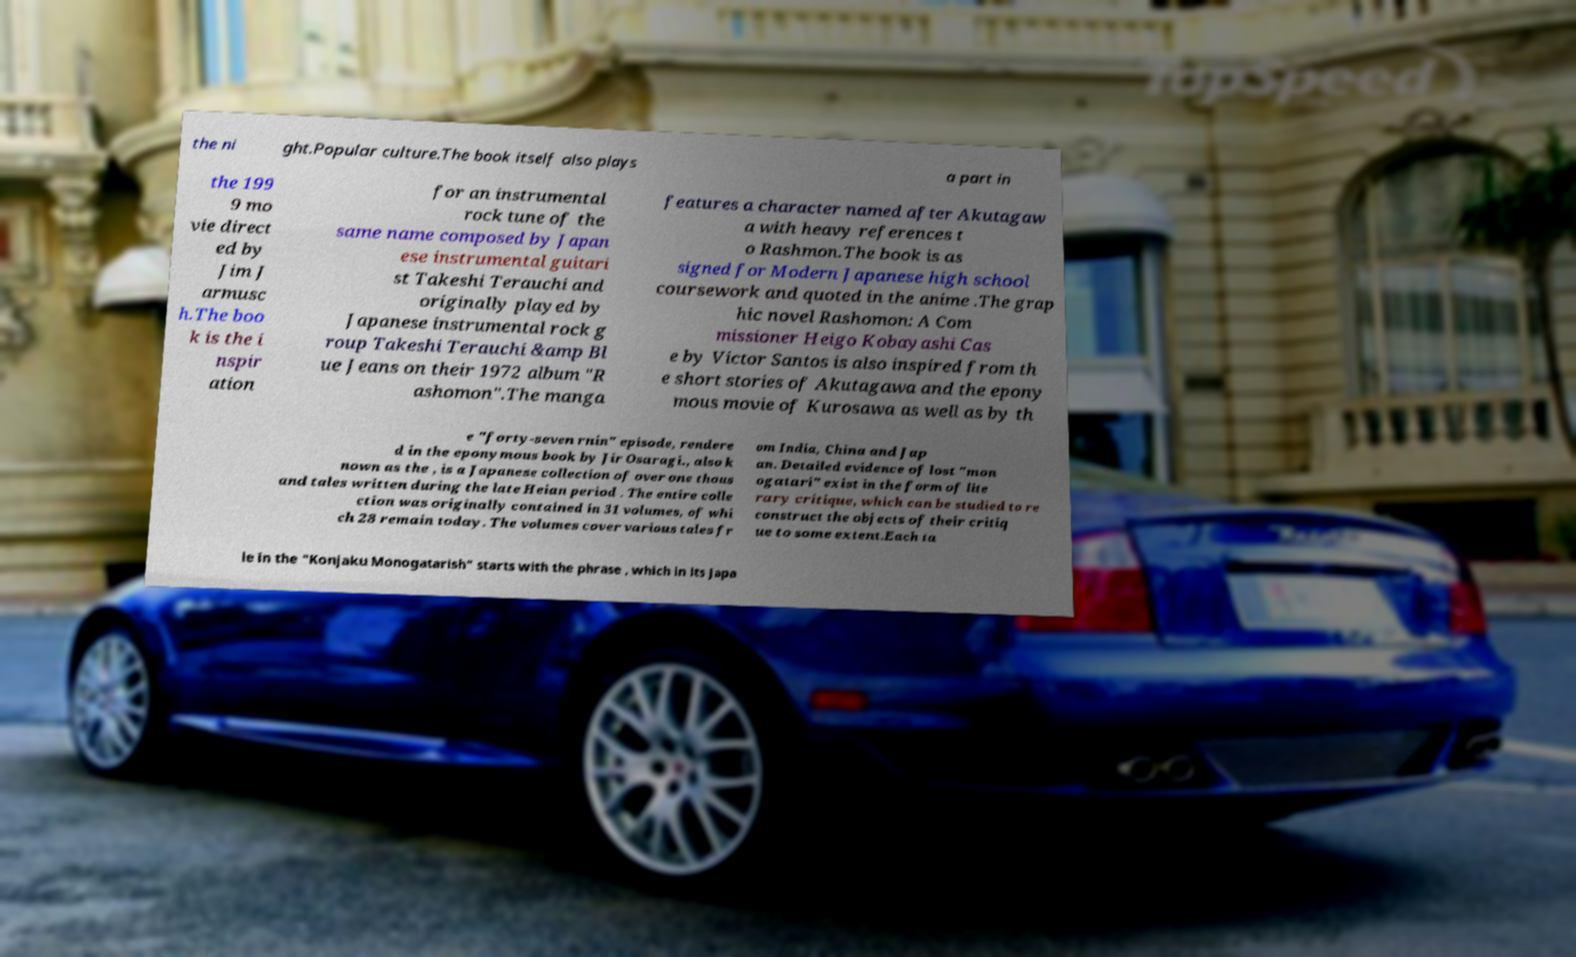Can you accurately transcribe the text from the provided image for me? the ni ght.Popular culture.The book itself also plays a part in the 199 9 mo vie direct ed by Jim J armusc h.The boo k is the i nspir ation for an instrumental rock tune of the same name composed by Japan ese instrumental guitari st Takeshi Terauchi and originally played by Japanese instrumental rock g roup Takeshi Terauchi &amp Bl ue Jeans on their 1972 album "R ashomon".The manga features a character named after Akutagaw a with heavy references t o Rashmon.The book is as signed for Modern Japanese high school coursework and quoted in the anime .The grap hic novel Rashomon: A Com missioner Heigo Kobayashi Cas e by Victor Santos is also inspired from th e short stories of Akutagawa and the epony mous movie of Kurosawa as well as by th e "forty-seven rnin" episode, rendere d in the eponymous book by Jir Osaragi., also k nown as the , is a Japanese collection of over one thous and tales written during the late Heian period . The entire colle ction was originally contained in 31 volumes, of whi ch 28 remain today. The volumes cover various tales fr om India, China and Jap an. Detailed evidence of lost "mon ogatari" exist in the form of lite rary critique, which can be studied to re construct the objects of their critiq ue to some extent.Each ta le in the "Konjaku Monogatarish" starts with the phrase , which in its Japa 